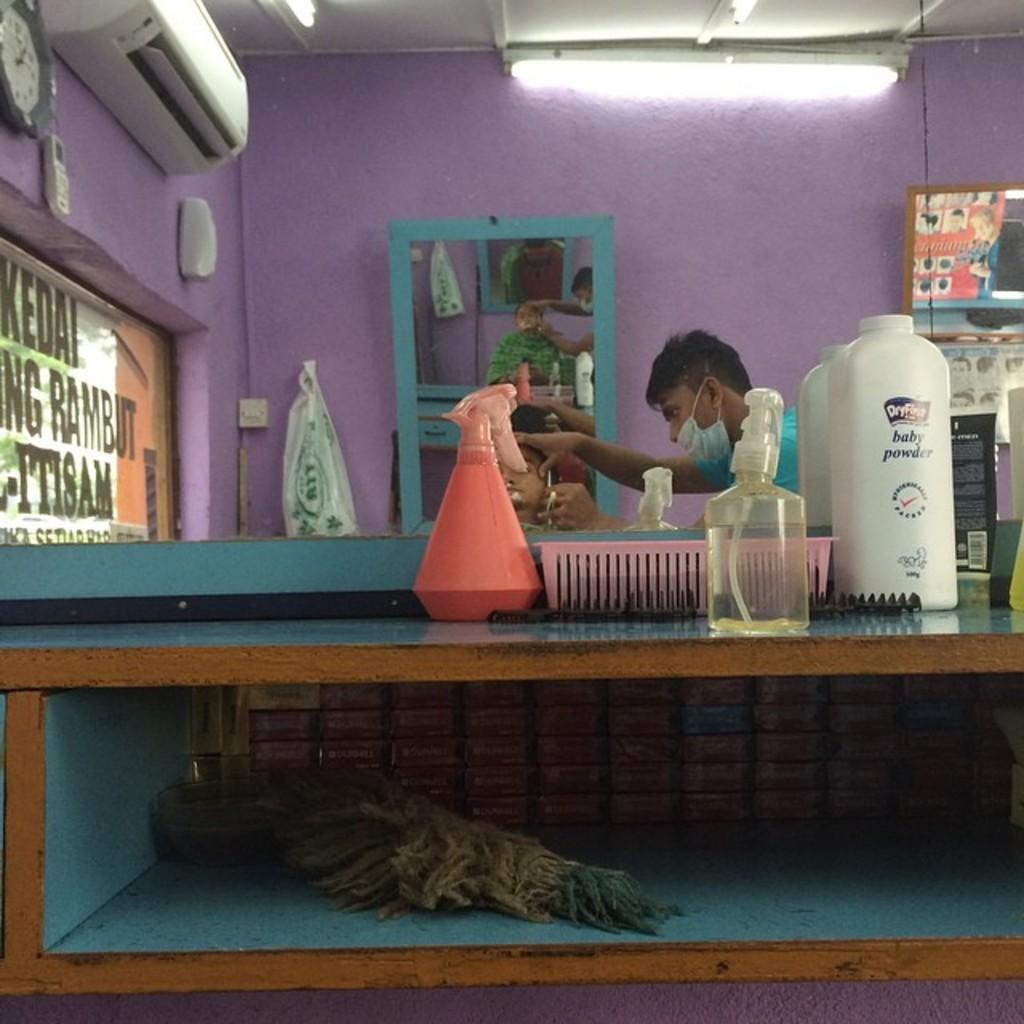<image>
Present a compact description of the photo's key features. Baby powder and some spray bottles sit on a shelf in a barbershop 